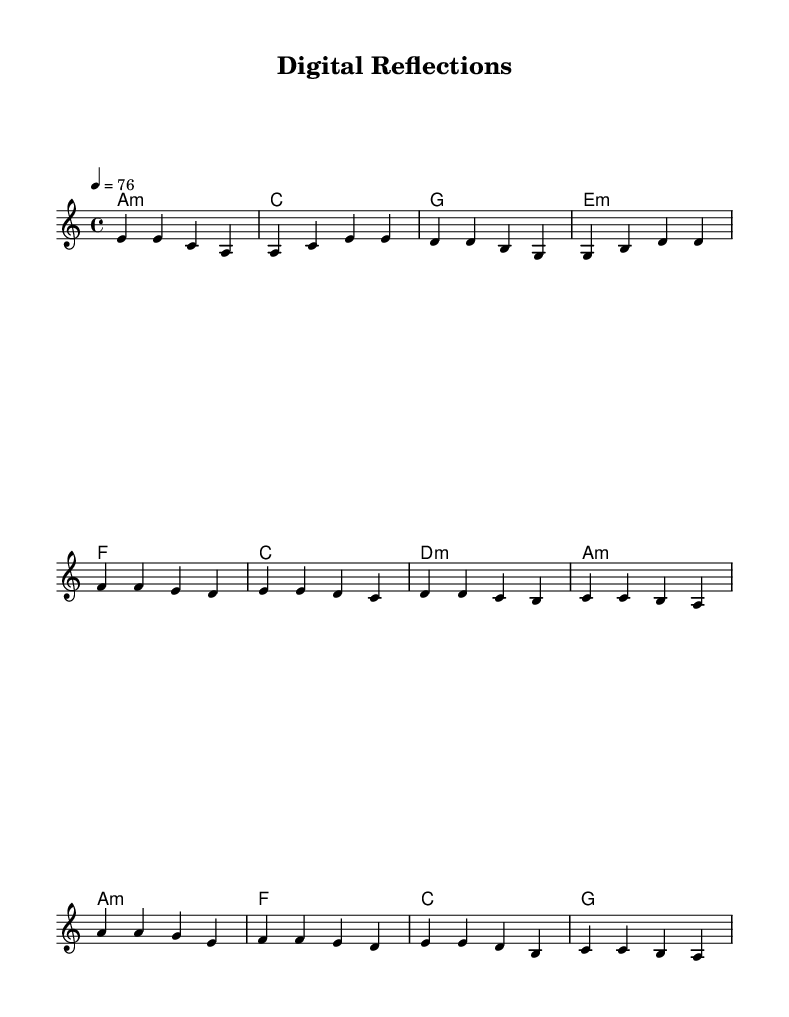What is the key signature of this music? The key signature is indicated at the beginning of the score, which shows 'A minor.' A minor has no sharps or flats.
Answer: A minor What is the time signature of this song? The time signature is shown at the beginning of the score, indicating 4/4 time. This means there are four beats per measure and the quarter note gets one beat.
Answer: 4/4 What is the tempo marking for this piece? The tempo marking appears in the score as '4 = 76,' indicating a moderate tempo of 76 beats per minute.
Answer: 76 How many measures are in the verse section? Counting the measures in the 'melody' part under the verse section, there are four measures in total.
Answer: 4 What is the first chord played in the chorus? By looking at the 'harmonies' section under the chorus, the first chord listed is 'A minor,' which indicates the harmony played during that part.
Answer: A minor In which section do we find a descending melodic line starting from the note A? The pre-chorus section contains a descending melodic line that begins with the note A and moves downward through other notes as indicated in the melody part.
Answer: Pre-Chorus What is the last chord in the song? The score indicates that the last chord in the 'harmonies' section is 'G,' which concludes the piece.
Answer: G 